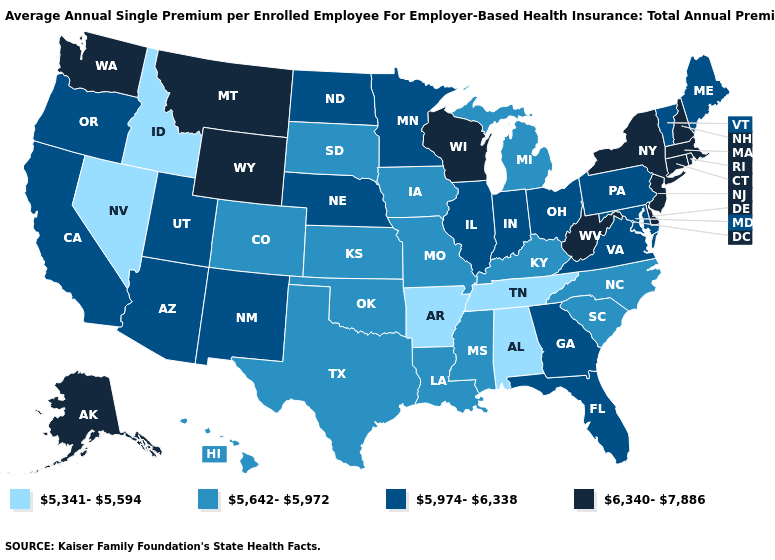Does Kansas have the same value as Arkansas?
Short answer required. No. Name the states that have a value in the range 5,642-5,972?
Short answer required. Colorado, Hawaii, Iowa, Kansas, Kentucky, Louisiana, Michigan, Mississippi, Missouri, North Carolina, Oklahoma, South Carolina, South Dakota, Texas. What is the value of Pennsylvania?
Keep it brief. 5,974-6,338. Does Idaho have the lowest value in the West?
Give a very brief answer. Yes. Name the states that have a value in the range 6,340-7,886?
Concise answer only. Alaska, Connecticut, Delaware, Massachusetts, Montana, New Hampshire, New Jersey, New York, Rhode Island, Washington, West Virginia, Wisconsin, Wyoming. Name the states that have a value in the range 6,340-7,886?
Write a very short answer. Alaska, Connecticut, Delaware, Massachusetts, Montana, New Hampshire, New Jersey, New York, Rhode Island, Washington, West Virginia, Wisconsin, Wyoming. What is the highest value in states that border Ohio?
Short answer required. 6,340-7,886. Does the first symbol in the legend represent the smallest category?
Answer briefly. Yes. Among the states that border Louisiana , does Texas have the highest value?
Answer briefly. Yes. Name the states that have a value in the range 5,642-5,972?
Write a very short answer. Colorado, Hawaii, Iowa, Kansas, Kentucky, Louisiana, Michigan, Mississippi, Missouri, North Carolina, Oklahoma, South Carolina, South Dakota, Texas. Does the map have missing data?
Give a very brief answer. No. What is the lowest value in states that border Louisiana?
Answer briefly. 5,341-5,594. What is the highest value in the MidWest ?
Concise answer only. 6,340-7,886. Name the states that have a value in the range 5,974-6,338?
Keep it brief. Arizona, California, Florida, Georgia, Illinois, Indiana, Maine, Maryland, Minnesota, Nebraska, New Mexico, North Dakota, Ohio, Oregon, Pennsylvania, Utah, Vermont, Virginia. 